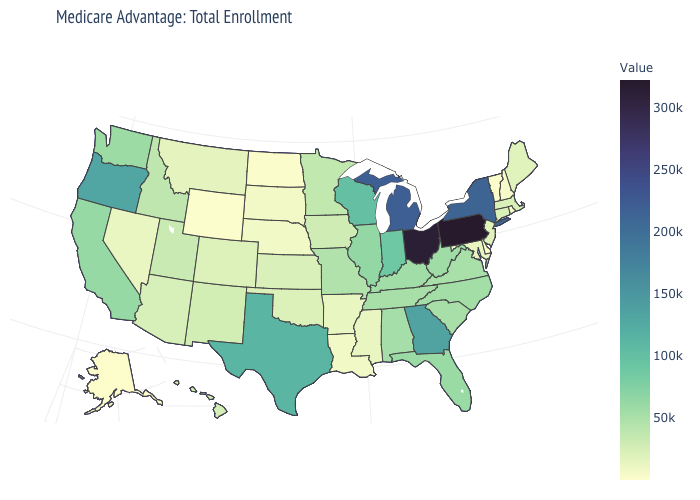Which states hav the highest value in the West?
Write a very short answer. Oregon. Is the legend a continuous bar?
Quick response, please. Yes. Does Pennsylvania have the highest value in the Northeast?
Quick response, please. Yes. Does the map have missing data?
Write a very short answer. No. Does Alaska have the lowest value in the West?
Concise answer only. Yes. 